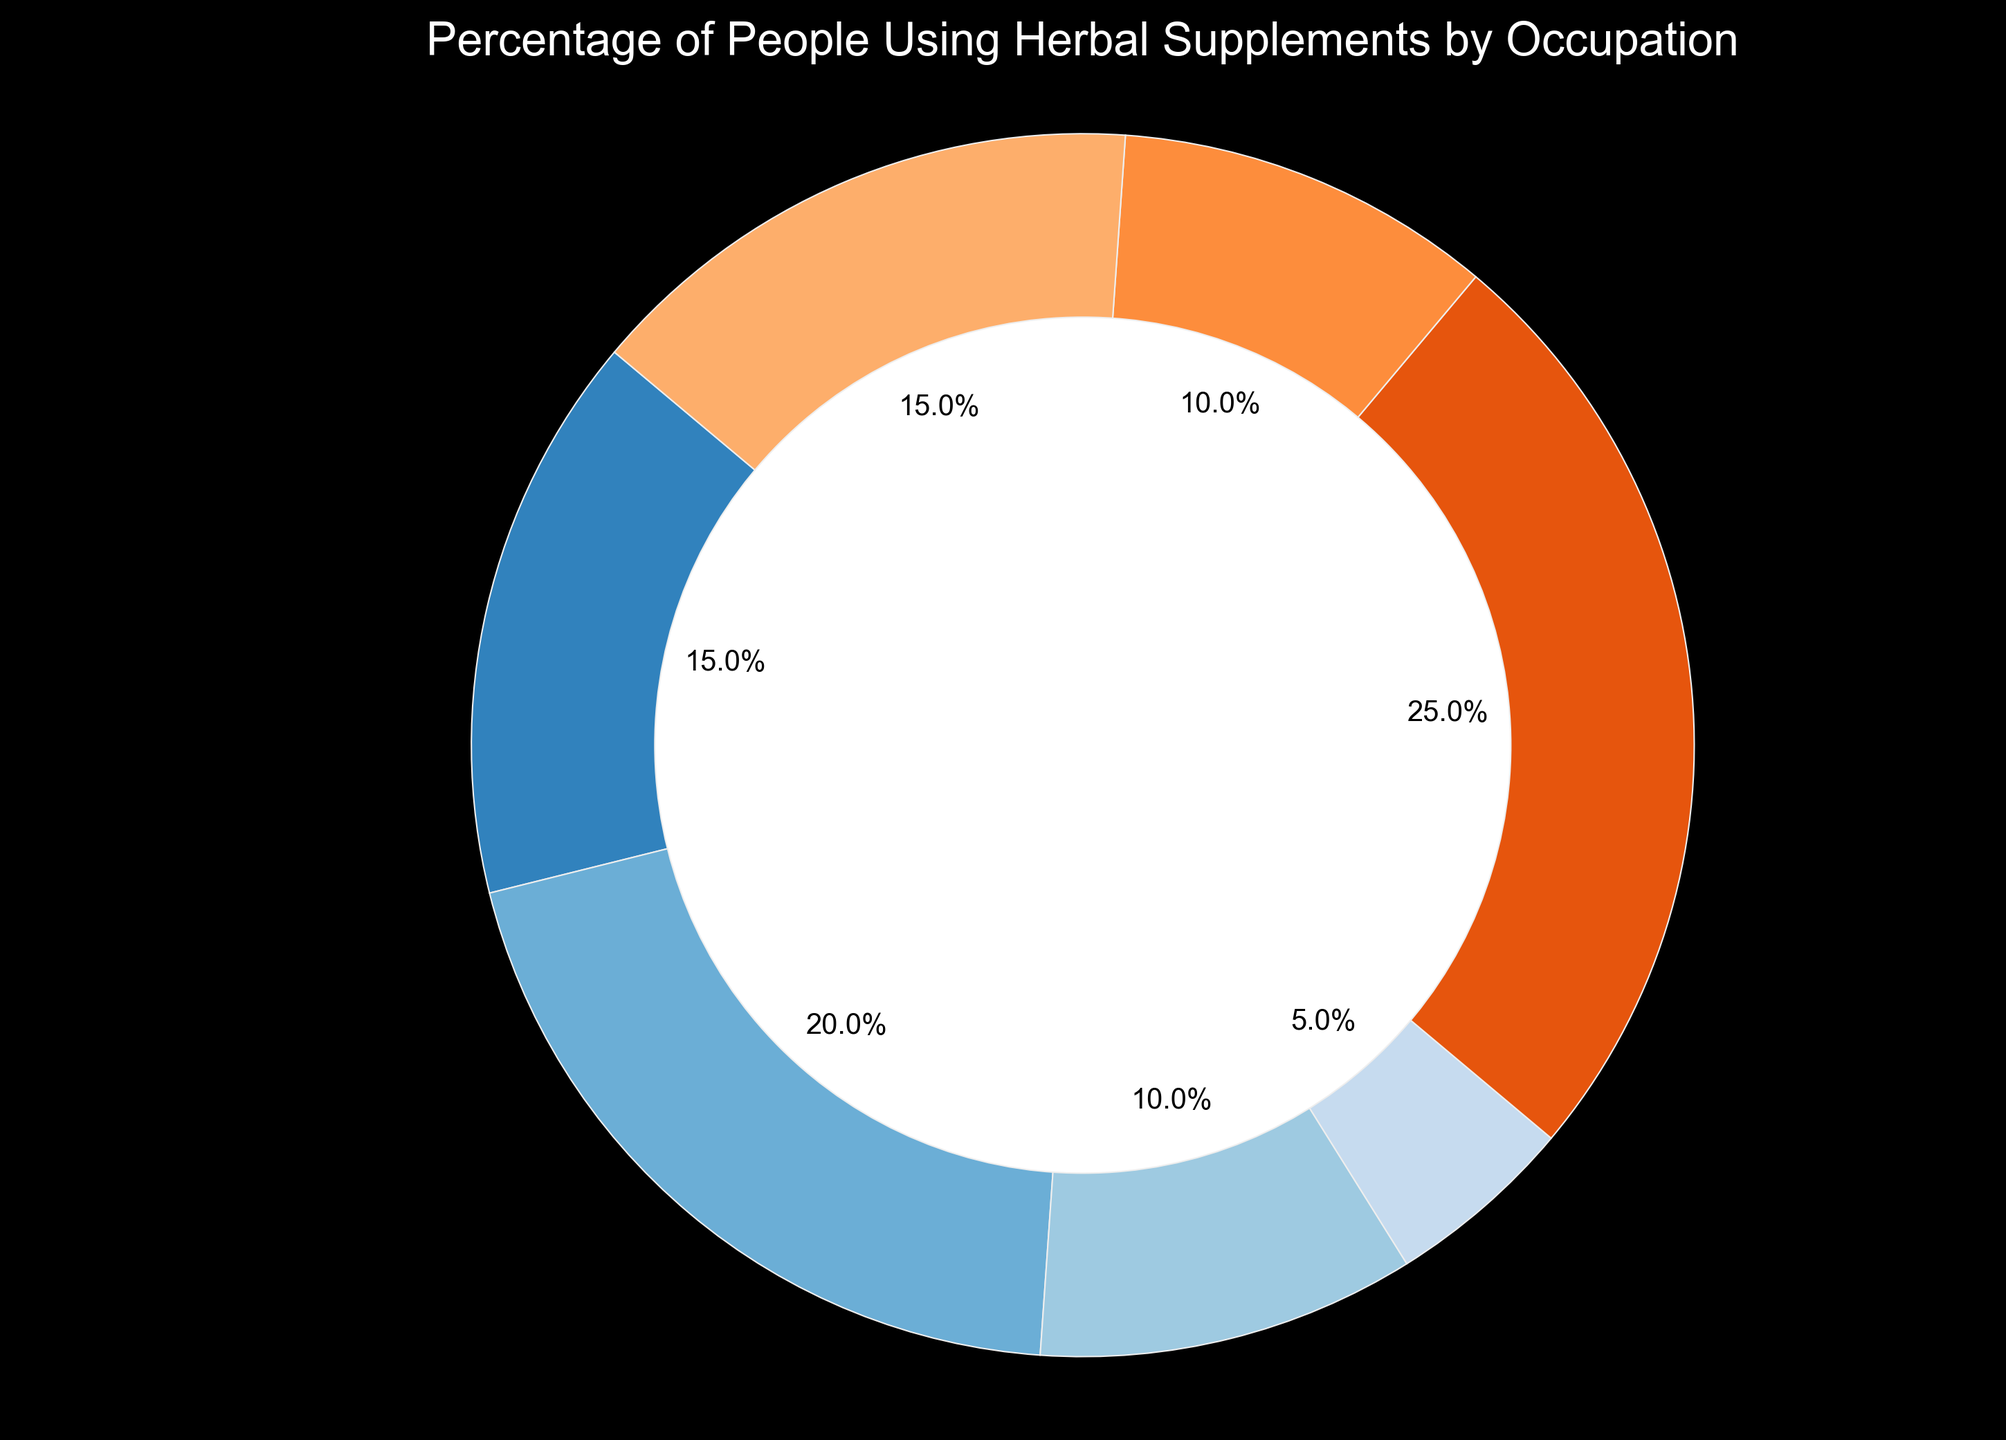Which occupation has the highest percentage of people using herbal supplements? By examining the slices of the pie chart, the occupation with the largest slice represents the highest percentage. The "Students" category occupies the largest portion of the chart.
Answer: Students Which two occupations have the same percentage of herbal supplement users? By comparing the sizes of the slices, it is evident that both "Teachers" and "Freelancers" have equally sized slices.
Answer: Teachers and Freelancers What is the total percentage of people using herbal supplements in Healthcare Workers and Retirees combined? Adding the two percentages from the healthcare workers (15%) and retirees (15%) slices gives 15% + 15% = 30%.
Answer: 30% How much larger is the percentage of herbal supplement users in Office Workers compared to Personal Trainers? Subtracting the percentage of personal trainers (5%) from the office workers (20%) gives 20% - 5% = 15%.
Answer: 15% Which group of workers has a smaller percentage of herbal supplement users than Teachers? By comparing the slices visually, the "Personal Trainers" category has a smaller percentage than "Teachers".
Answer: Personal Trainers What is the combined percentage of all occupations except for Students? Subtracting the percentage of students (25%) from the total 100% gives 100% - 25% = 75%.
Answer: 75% What is the average percentage of herbal supplement users in the Freelancer, Teacher, and Retiree categories? Adding their percentages and dividing by the number of categories: (10% + 10% + 15%) / 3 = 35% / 3 = 11.67%.
Answer: 11.67% Do healthcare workers or retirees have a higher percentage of people using herbal supplements? By comparing the sizes of the slices, both healthcare workers and retirees have the same percentage (15%).
Answer: Equal Which color represents the Personal Trainers category, and how does it visually compare with other categories? The color representing Personal Trainers is visually identified on the pie chart and is typically smaller than most other categories except for Teachers and Freelancers.
Answer: The color and size are smaller than most categories 